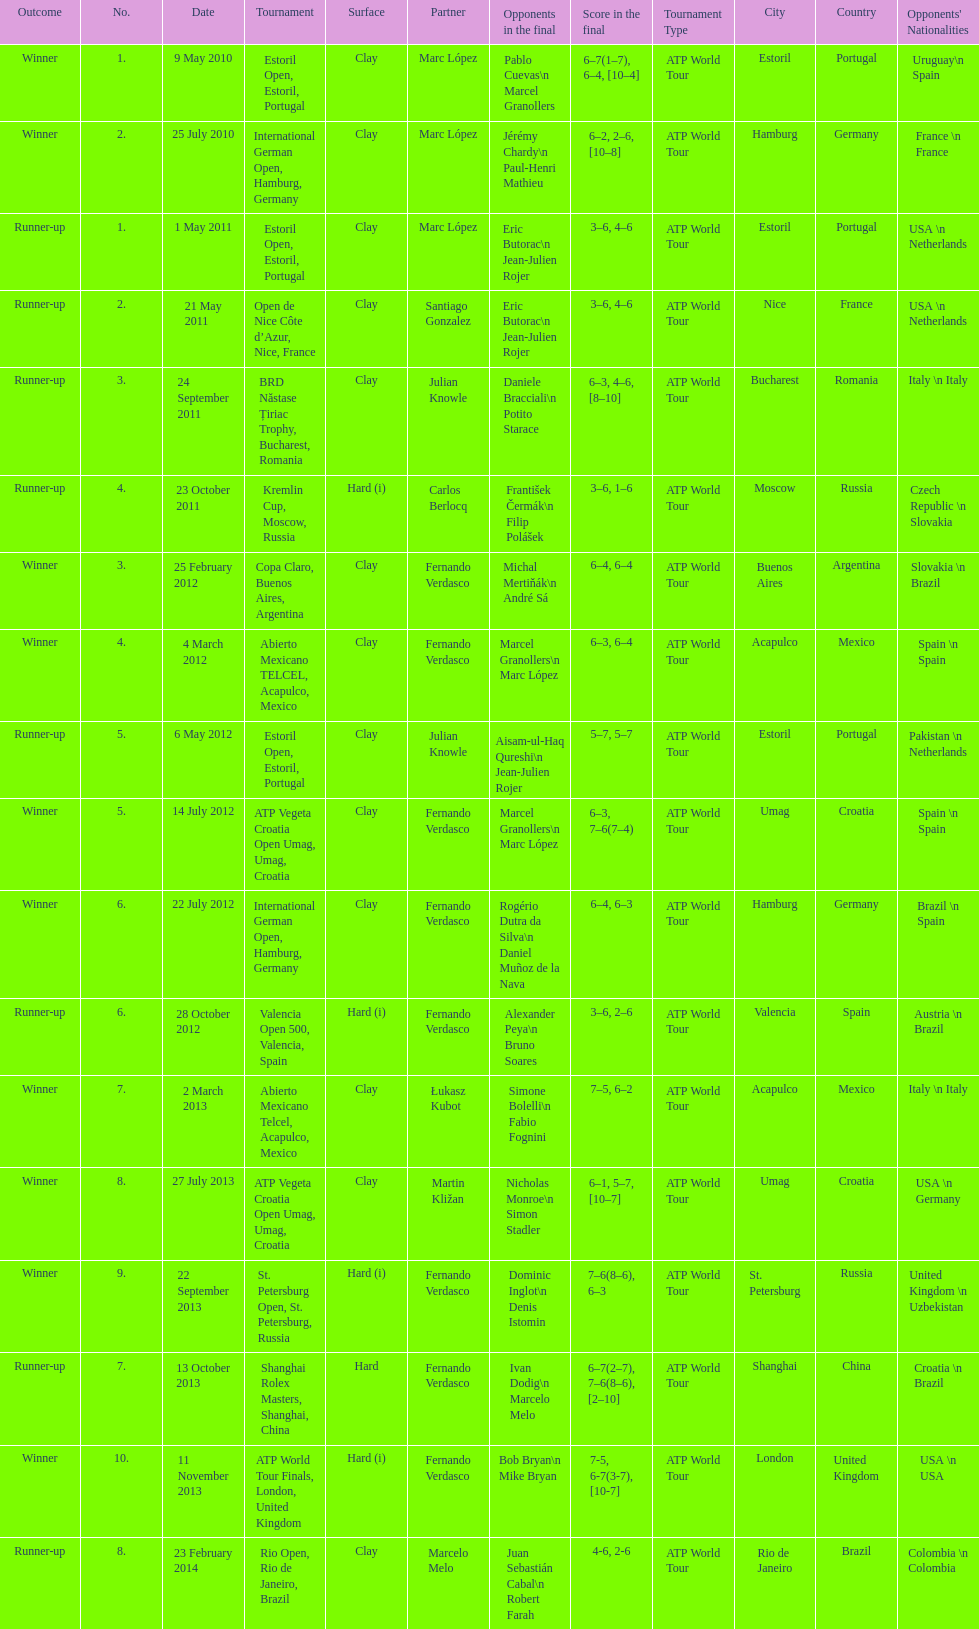What is the number of winning outcomes? 10. 